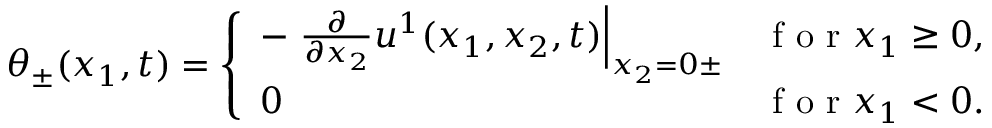Convert formula to latex. <formula><loc_0><loc_0><loc_500><loc_500>\theta _ { \pm } ( x _ { 1 } , t ) = \left \{ \begin{array} { l l } { - \frac { \partial } { \partial x _ { 2 } } u ^ { 1 } ( x _ { 1 } , x _ { 2 } , t ) \right | _ { x _ { 2 } = 0 \pm } } & { f o r x _ { 1 } \geq 0 , } \\ { 0 } & { f o r x _ { 1 } < 0 . } \end{array}</formula> 